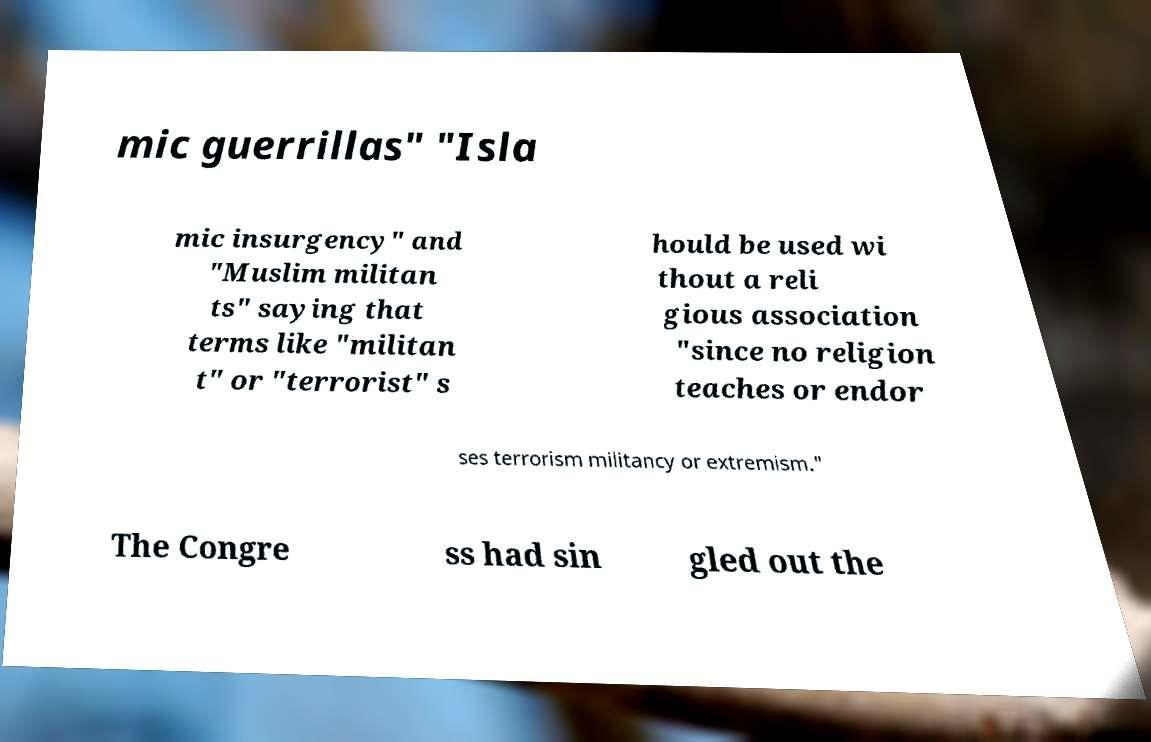Can you accurately transcribe the text from the provided image for me? mic guerrillas" "Isla mic insurgency" and "Muslim militan ts" saying that terms like "militan t" or "terrorist" s hould be used wi thout a reli gious association "since no religion teaches or endor ses terrorism militancy or extremism." The Congre ss had sin gled out the 